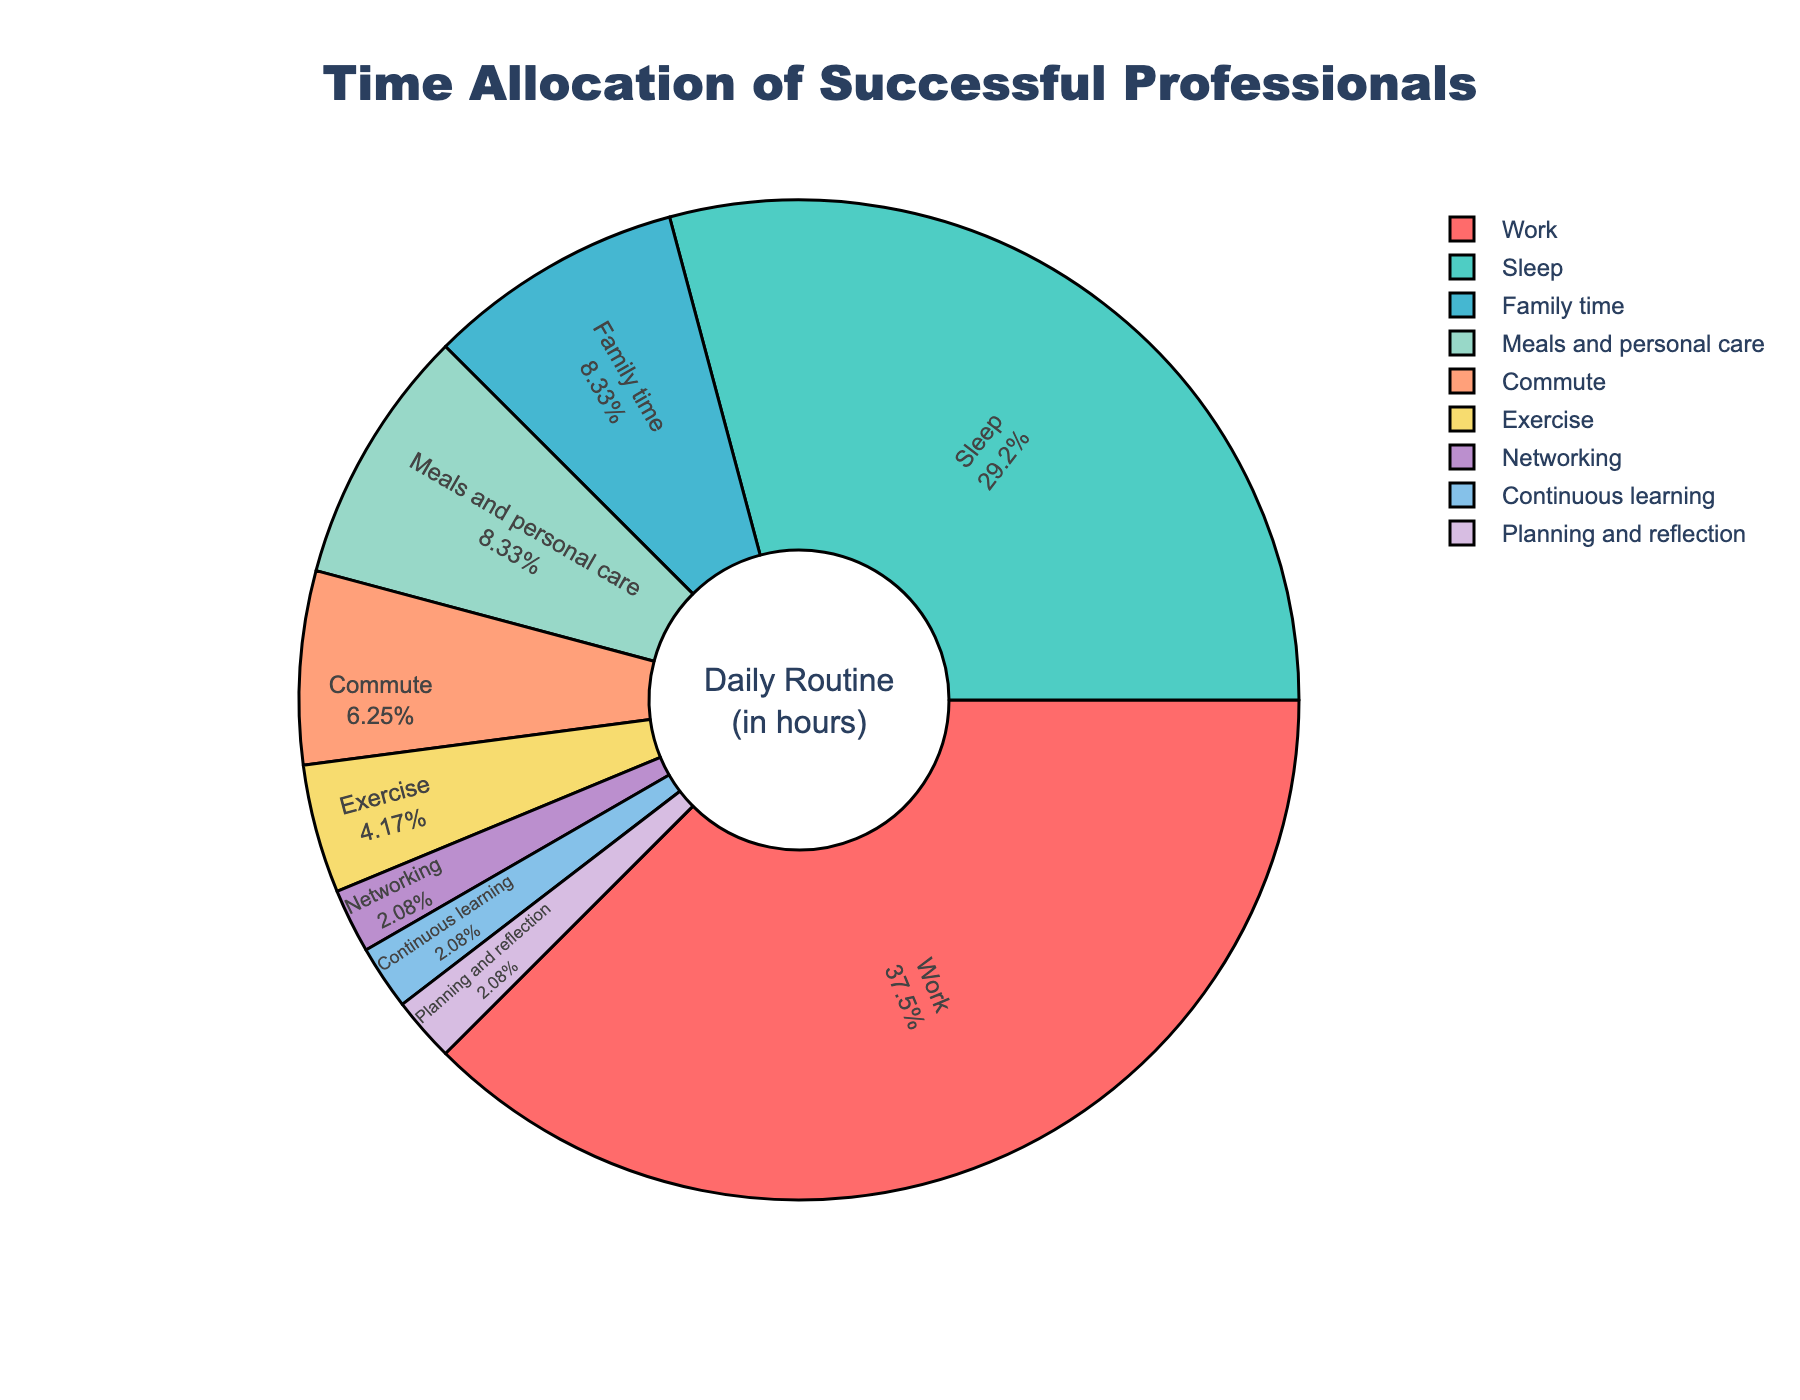what are the two activities where successful professionals spend the least amount of time? The figure shows that successful professionals spend the least amount of time on Networking and Continuous learning, each with a very small percentage of the daily routine.
Answer: Networking and Continuous learning How many more hours do successful professionals spend on work compared to family time? The pie chart shows professionals work for 9 hours and spend 2 hours on family time. The difference is 9 - 2 = 7 hours.
Answer: 7 hours Which activity has the third highest allocation of time? By visually inspecting the slices from largest to smallest, the third largest slice represents Family time with 2 hours.
Answer: Family time What's the total time spent by successful professionals on commute, meals and personal care, and exercise? Commute has 1.5 hours, meals and personal care has 2 hours, and exercise has 1 hour. Summing them up: 1.5 + 2 + 1 = 4.5 hours.
Answer: 4.5 hours What fraction of the day do successful professionals dedicate to sleep, and how does this compare to their work hours? Successful professionals spend 7 hours sleeping. The total hours in a day are 24, so the fraction is 7/24. Comparing with work hours: fraction for work is 9/24. Sleep (7/24) is less than work (9/24).
Answer: 7/24, less than work What percentage of time is spent on planning and reflection and continuous learning combined? Each activity of planning and reflection, and continuous learning are listed as 0.5 hours. Combining them: 0.5 + 0.5 = 1 hour out of 24 hours in total. Converting to percentage: (1/24) * 100 ≈ 4.17%.
Answer: 4.17% Which activity represents the smallest portion of the pie chart? Visually, the smallest slice of the pie chart is labeled as Networking with 0.5 hours.
Answer: Networking 